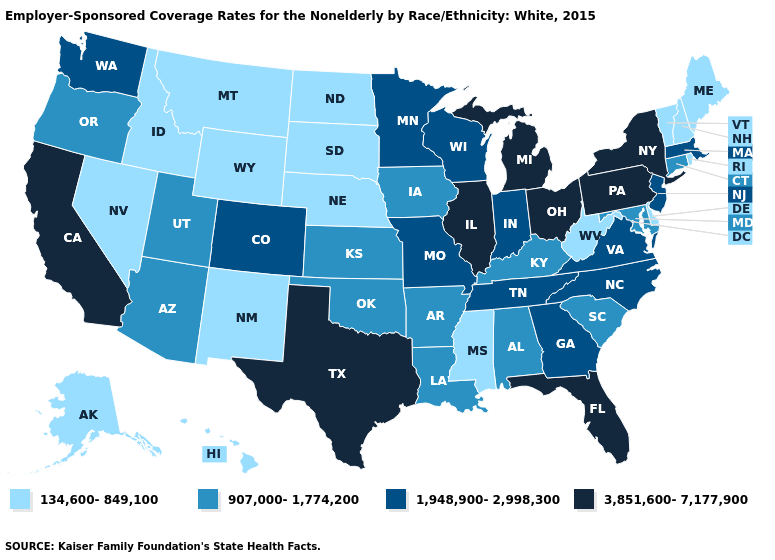Does the map have missing data?
Quick response, please. No. Name the states that have a value in the range 907,000-1,774,200?
Short answer required. Alabama, Arizona, Arkansas, Connecticut, Iowa, Kansas, Kentucky, Louisiana, Maryland, Oklahoma, Oregon, South Carolina, Utah. What is the value of West Virginia?
Keep it brief. 134,600-849,100. Does West Virginia have the highest value in the South?
Answer briefly. No. What is the value of North Carolina?
Short answer required. 1,948,900-2,998,300. Which states hav the highest value in the MidWest?
Keep it brief. Illinois, Michigan, Ohio. Which states hav the highest value in the MidWest?
Quick response, please. Illinois, Michigan, Ohio. Does Arizona have the lowest value in the USA?
Give a very brief answer. No. Name the states that have a value in the range 907,000-1,774,200?
Short answer required. Alabama, Arizona, Arkansas, Connecticut, Iowa, Kansas, Kentucky, Louisiana, Maryland, Oklahoma, Oregon, South Carolina, Utah. What is the lowest value in the USA?
Answer briefly. 134,600-849,100. Name the states that have a value in the range 1,948,900-2,998,300?
Answer briefly. Colorado, Georgia, Indiana, Massachusetts, Minnesota, Missouri, New Jersey, North Carolina, Tennessee, Virginia, Washington, Wisconsin. Does Georgia have a higher value than New York?
Answer briefly. No. Which states have the lowest value in the USA?
Write a very short answer. Alaska, Delaware, Hawaii, Idaho, Maine, Mississippi, Montana, Nebraska, Nevada, New Hampshire, New Mexico, North Dakota, Rhode Island, South Dakota, Vermont, West Virginia, Wyoming. Does New York have the highest value in the USA?
Keep it brief. Yes. 